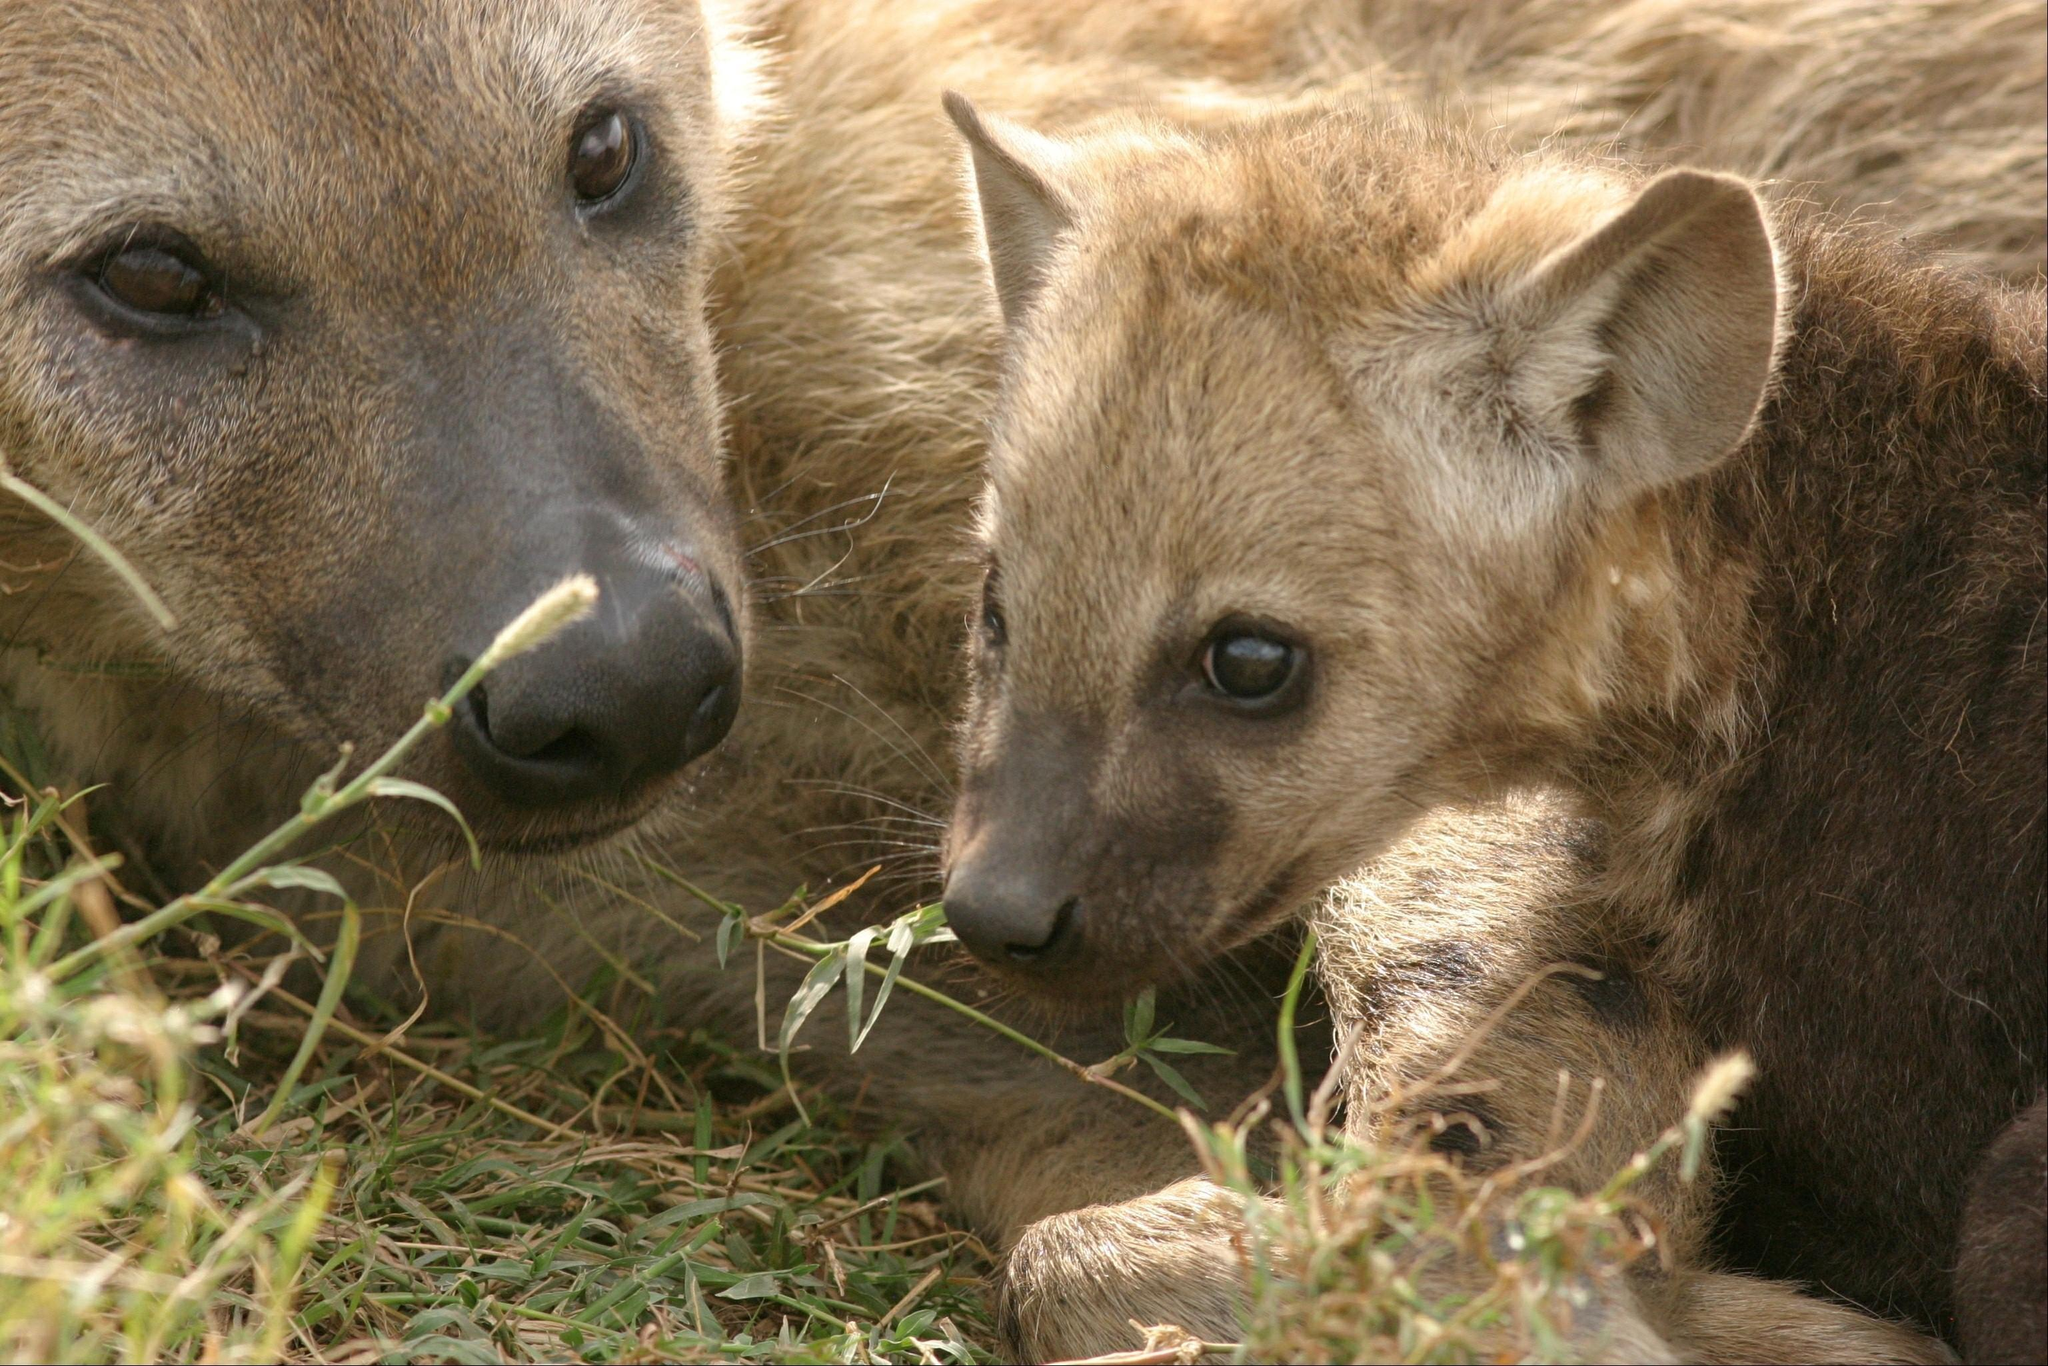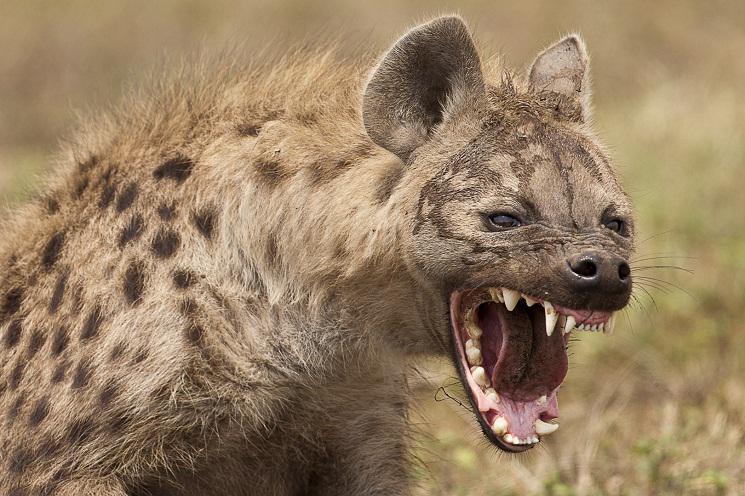The first image is the image on the left, the second image is the image on the right. Examine the images to the left and right. Is the description "The hyena on the right image is facing left." accurate? Answer yes or no. No. 